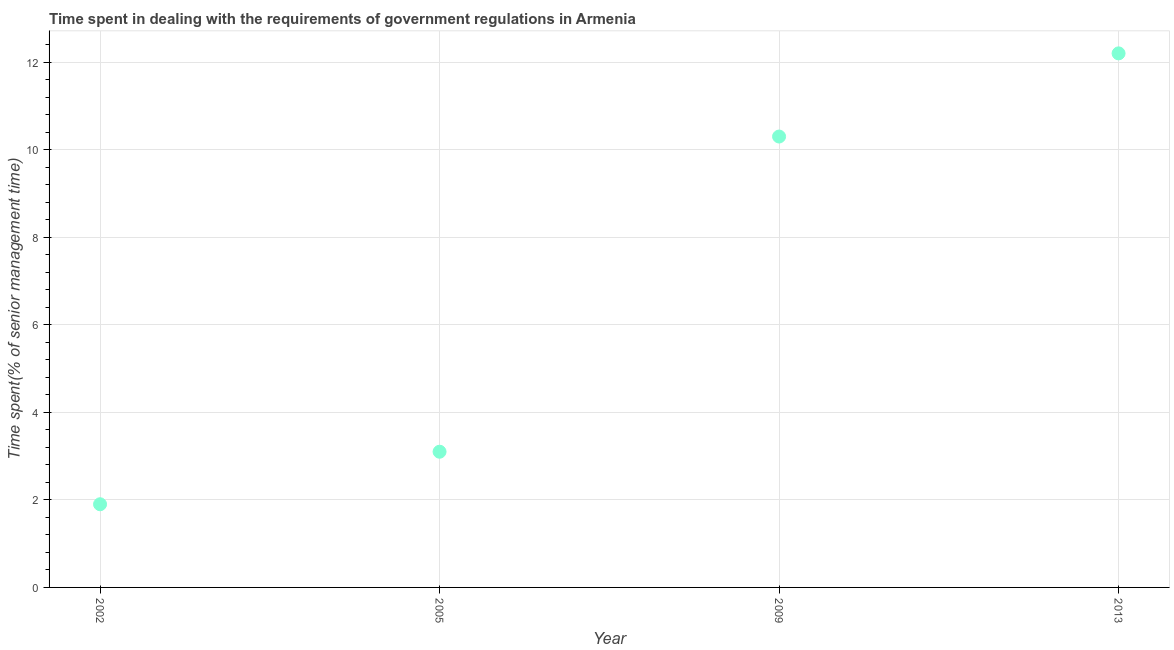What is the time spent in dealing with government regulations in 2002?
Provide a succinct answer. 1.9. Across all years, what is the minimum time spent in dealing with government regulations?
Ensure brevity in your answer.  1.9. In which year was the time spent in dealing with government regulations maximum?
Provide a succinct answer. 2013. What is the difference between the time spent in dealing with government regulations in 2005 and 2009?
Your answer should be very brief. -7.2. What is the average time spent in dealing with government regulations per year?
Your answer should be compact. 6.88. What is the median time spent in dealing with government regulations?
Make the answer very short. 6.7. What is the ratio of the time spent in dealing with government regulations in 2002 to that in 2013?
Give a very brief answer. 0.16. Is the difference between the time spent in dealing with government regulations in 2002 and 2005 greater than the difference between any two years?
Provide a short and direct response. No. What is the difference between the highest and the second highest time spent in dealing with government regulations?
Provide a succinct answer. 1.9. What is the difference between the highest and the lowest time spent in dealing with government regulations?
Provide a short and direct response. 10.3. In how many years, is the time spent in dealing with government regulations greater than the average time spent in dealing with government regulations taken over all years?
Keep it short and to the point. 2. Does the graph contain grids?
Your answer should be compact. Yes. What is the title of the graph?
Keep it short and to the point. Time spent in dealing with the requirements of government regulations in Armenia. What is the label or title of the X-axis?
Ensure brevity in your answer.  Year. What is the label or title of the Y-axis?
Ensure brevity in your answer.  Time spent(% of senior management time). What is the Time spent(% of senior management time) in 2002?
Offer a terse response. 1.9. What is the Time spent(% of senior management time) in 2009?
Your answer should be compact. 10.3. What is the Time spent(% of senior management time) in 2013?
Make the answer very short. 12.2. What is the difference between the Time spent(% of senior management time) in 2002 and 2009?
Provide a succinct answer. -8.4. What is the difference between the Time spent(% of senior management time) in 2002 and 2013?
Your answer should be compact. -10.3. What is the difference between the Time spent(% of senior management time) in 2009 and 2013?
Offer a terse response. -1.9. What is the ratio of the Time spent(% of senior management time) in 2002 to that in 2005?
Provide a succinct answer. 0.61. What is the ratio of the Time spent(% of senior management time) in 2002 to that in 2009?
Offer a terse response. 0.18. What is the ratio of the Time spent(% of senior management time) in 2002 to that in 2013?
Your answer should be compact. 0.16. What is the ratio of the Time spent(% of senior management time) in 2005 to that in 2009?
Make the answer very short. 0.3. What is the ratio of the Time spent(% of senior management time) in 2005 to that in 2013?
Your answer should be compact. 0.25. What is the ratio of the Time spent(% of senior management time) in 2009 to that in 2013?
Keep it short and to the point. 0.84. 